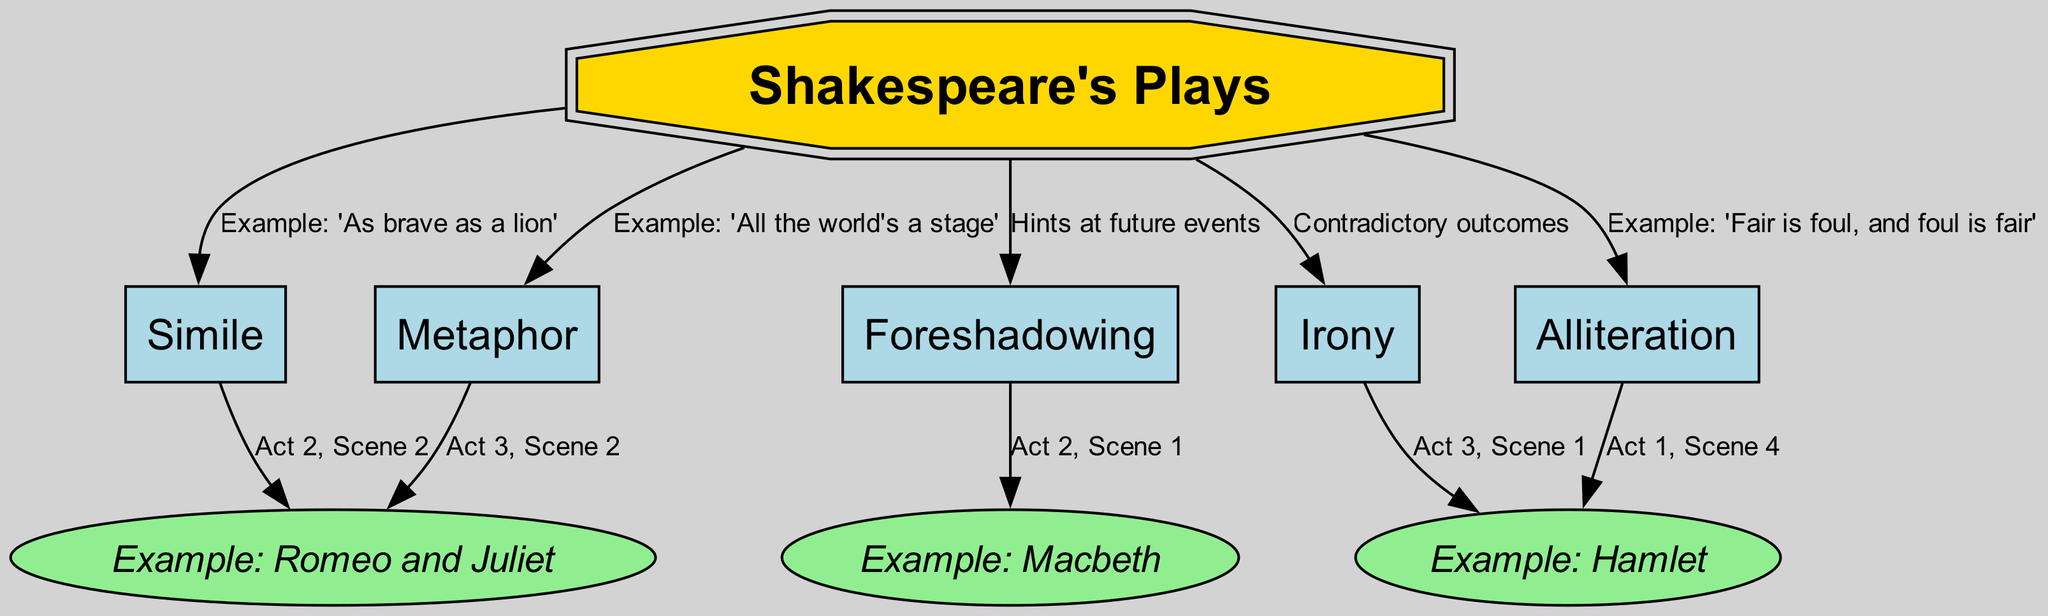What is the main subject of the diagram? The main subject, shown as the central node (1), is "Shakespeare's Plays." It provides the overall topic around which other nodes revolve.
Answer: Shakespeare's Plays How many literary devices are listed in the diagram? By counting the nodes connected to the central node, there are six literary devices: Metaphor, Simile, Alliteration, Foreshadowing, and Irony.
Answer: 6 What phrase illustrates the use of metaphor? The edge from node 2 to node 1 contains the label stating "Example: 'All the world's a stage'," which is the phrase illustrating the use of metaphor.
Answer: Example: 'All the world's a stage' In which act and scene does the use of simile appear in "Romeo and Juliet"? The edge from node 3 to node 7 designates the chapter as "Act 2, Scene 2," where simile is used in "Romeo and Juliet."
Answer: Act 2, Scene 2 What is the purpose of foreshadowing as denoted in the diagram? The edge from node 5 to node 9 says "Hints at future events," indicating the main purpose of foreshadowing as presented in the diagram.
Answer: Hints at future events Which play uses alliteration in Act 1, Scene 4? The edge from node 4 to node 8 indicates that "Example: 'Fair is foul, and foul is fair'" demonstrates alliteration in "Hamlet."
Answer: Example: 'Fair is foul, and foul is fair' How does irony present itself in "Hamlet"? The label on the edge from node 6 to node 8 suggests that irony is illustrated by "Contradictory outcomes," showcasing how it manifests within the play.
Answer: Contradictory outcomes Which literary device hints at future events? The node corresponding to foreshadowing (5) directly refers to its function of hinting at future events in Shakespeare's narrative style.
Answer: Foreshadowing What devices are connected to "Example: Macbeth"? The diagram shows that both foreshadowing (5) and metaphor (2) connect to the example of "Macbeth," indicating their usage in the play.
Answer: Foreshadowing, Metaphor 